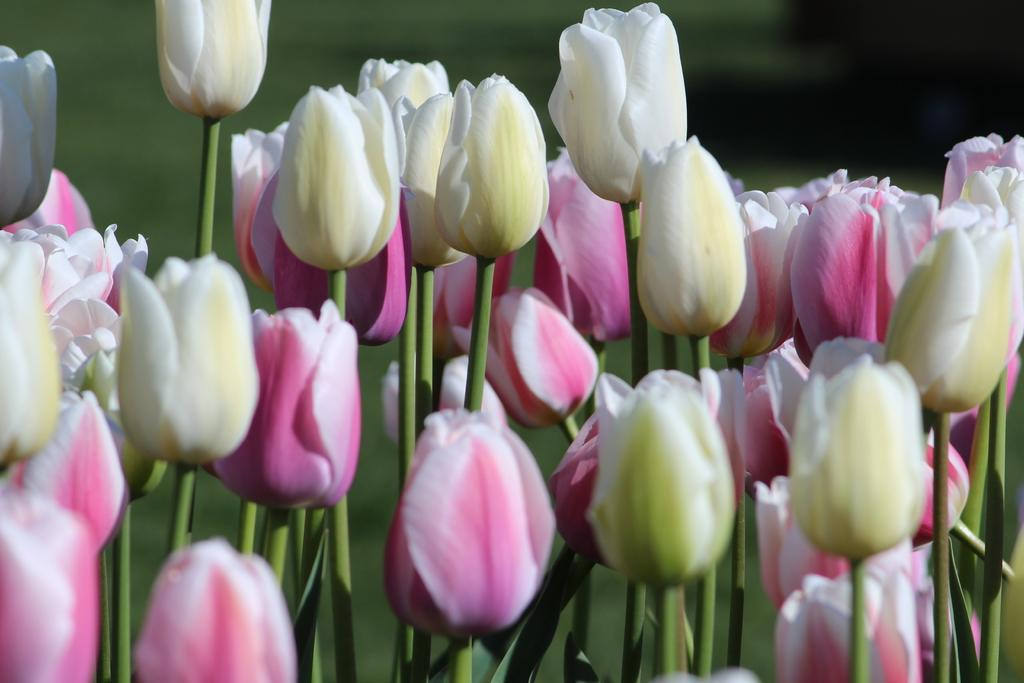What type of plants are in the image? There are flowers in the image. What part of the flowers can be seen in the image? The flowers have stems in the image. What color is the background of the image? The background of the image is green and blurred. How many eyes can be seen on the flowers in the image? Flowers do not have eyes, so there are no eyes visible on the flowers in the image. 